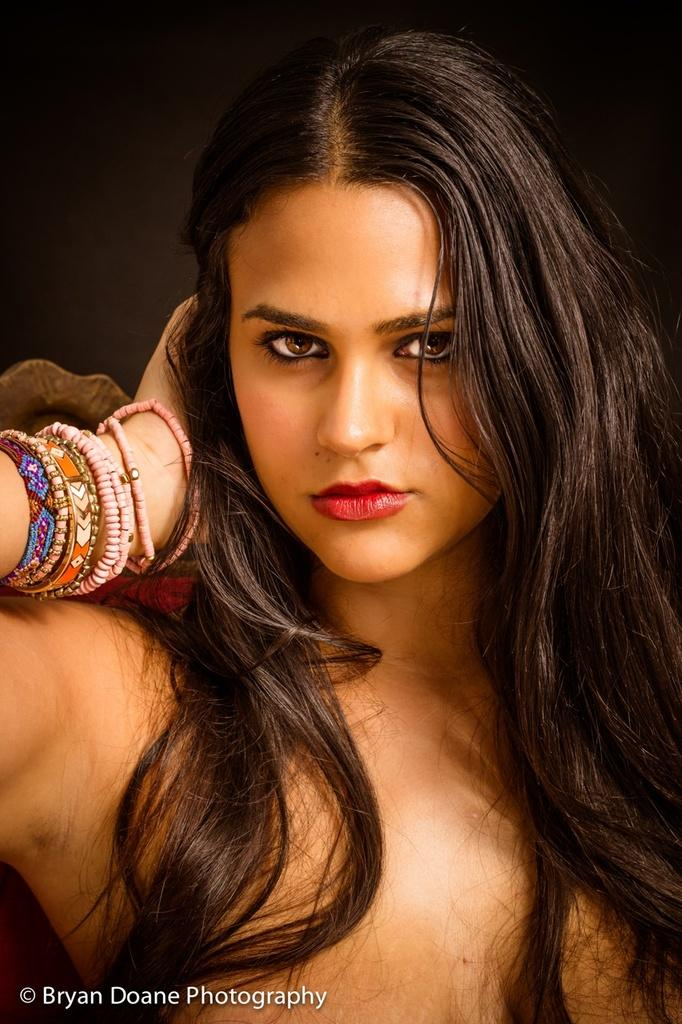What is the main subject of the image? The main subject of the image is a woman's face. What accessories is the woman wearing on her wrists? The woman is wearing wristbands and bangles. What decision is the woman making in the image? There is no indication of a decision being made in the image; it only shows the woman's face and her accessories. 